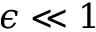Convert formula to latex. <formula><loc_0><loc_0><loc_500><loc_500>\epsilon \ll 1</formula> 